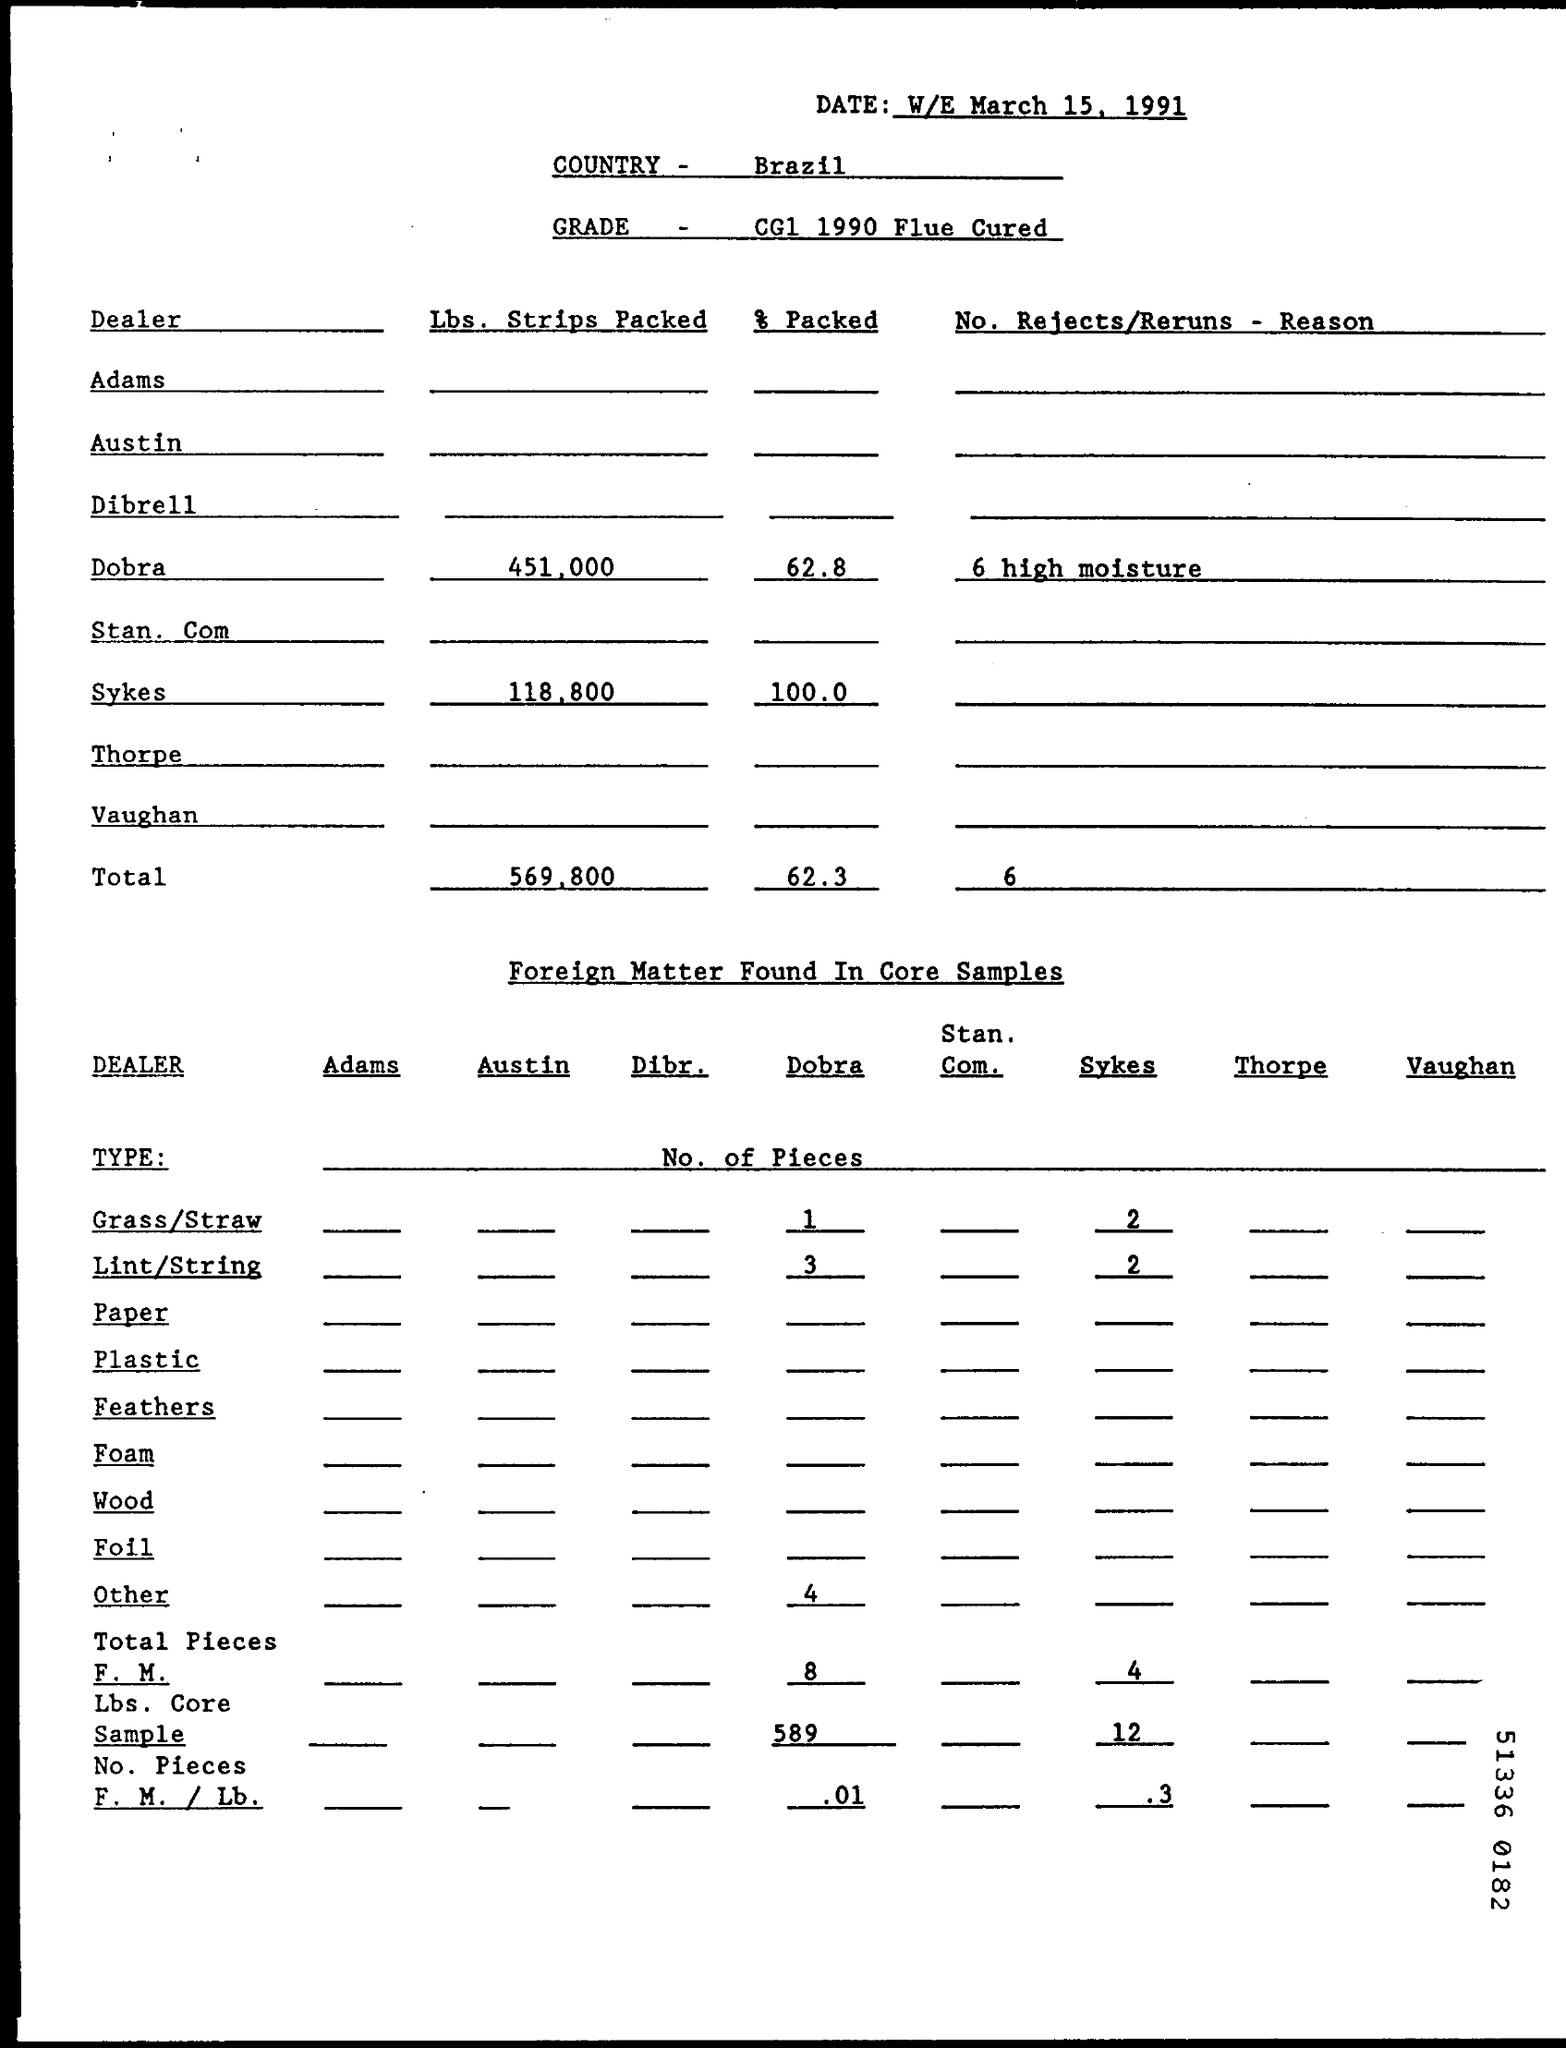List a handful of essential elements in this visual. The document indicates that the date is March 15, 1991. The Lbs. Strips packed for Dobra are 451,000. The % Packed for Sykes is 100.0%. Brazil is a country located in South America. The total percentage packed is 62.3... 